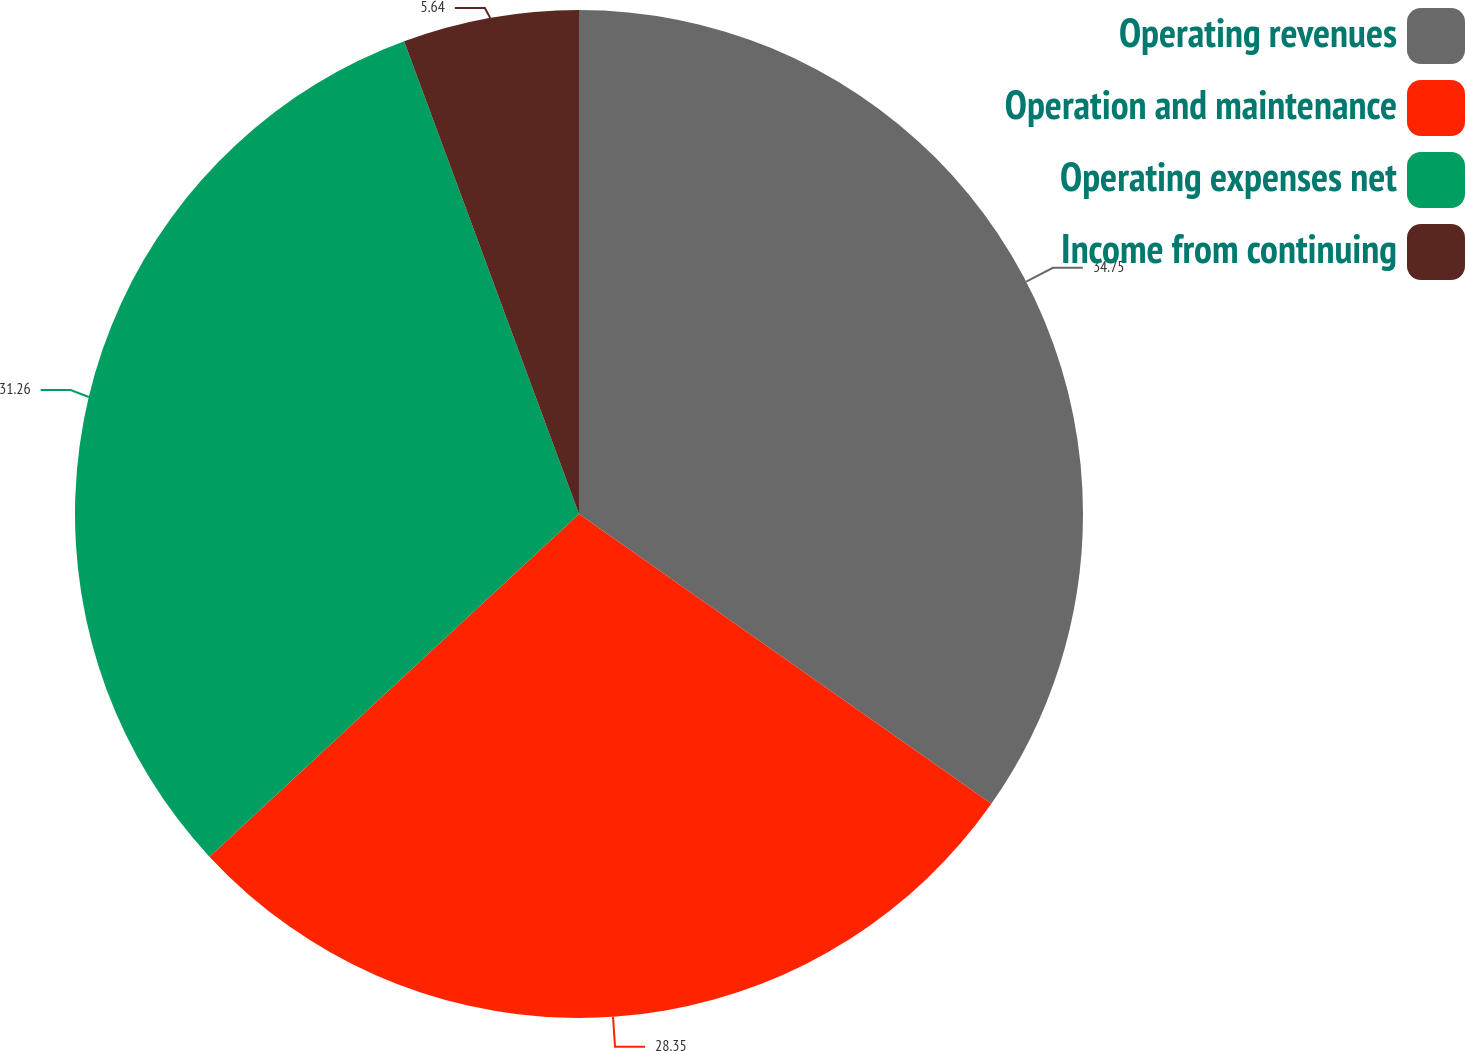<chart> <loc_0><loc_0><loc_500><loc_500><pie_chart><fcel>Operating revenues<fcel>Operation and maintenance<fcel>Operating expenses net<fcel>Income from continuing<nl><fcel>34.75%<fcel>28.35%<fcel>31.26%<fcel>5.64%<nl></chart> 